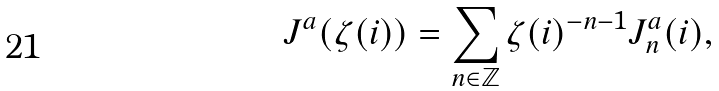<formula> <loc_0><loc_0><loc_500><loc_500>J ^ { a } ( \zeta ( i ) ) = \sum _ { n \in \mathbb { Z } } \zeta ( i ) ^ { - n - 1 } J _ { n } ^ { a } ( i ) ,</formula> 